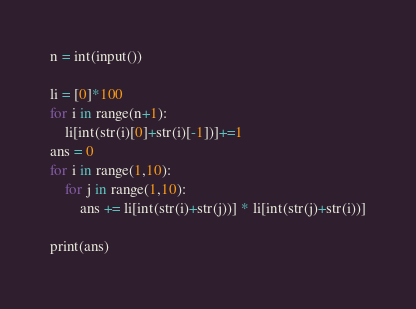<code> <loc_0><loc_0><loc_500><loc_500><_Python_>n = int(input())

li = [0]*100
for i in range(n+1):
    li[int(str(i)[0]+str(i)[-1])]+=1
ans = 0
for i in range(1,10):
    for j in range(1,10):
        ans += li[int(str(i)+str(j))] * li[int(str(j)+str(i))]

print(ans)
</code> 